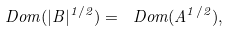<formula> <loc_0><loc_0><loc_500><loc_500>\ D o m ( | B | ^ { 1 / 2 } ) = \ D o m ( A ^ { 1 / 2 } ) ,</formula> 